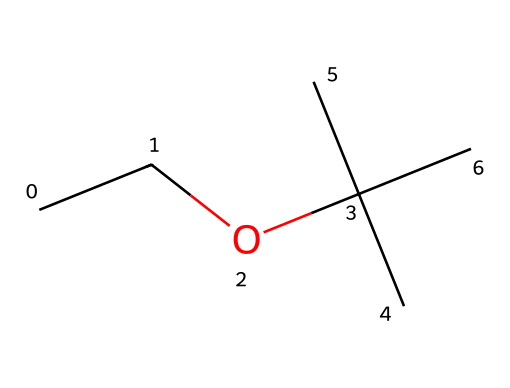What type of functional group is present in ethyl tert-butyl ether? The structure features an ether functional group, which is characterized by the R-O-R' linkage, where R and R' are alkyl groups. The oxygen atom connects two carbon-containing groups.
Answer: ether How many carbon atoms are in ethyl tert-butyl ether? Counting the carbon atoms in the structure: there are two in the ethyl group and four in the tert-butyl group, totaling six carbon atoms.
Answer: six What is the molecular formula of ethyl tert-butyl ether? To derive the molecular formula, count the atoms: 6 carbons, 14 hydrogens, and 1 oxygen. Thus, the formula is C6H14O.
Answer: C6H14O Is ethyl tert-butyl ether a polar or non-polar molecule? Given the presence of the ether functional group, which has an oxygen atom that can lead to polarity, but the bulky tert-butyl group lowers overall polarity, making it mostly non-polar.
Answer: non-polar Which part of the structure indicates it is an ether? The connecting oxygen atom between the two hydrocarbon groups signifies it is an ether, as it forms the characteristic R-O-R' structure typical of ethers.
Answer: oxygen atom How many hydrogen atoms are bonded to the central carbon in the tert-butyl group? In the tert-butyl portion, the central carbon is bonded to three other carbons and thus has no hydrogen atoms directly attached.
Answer: zero 